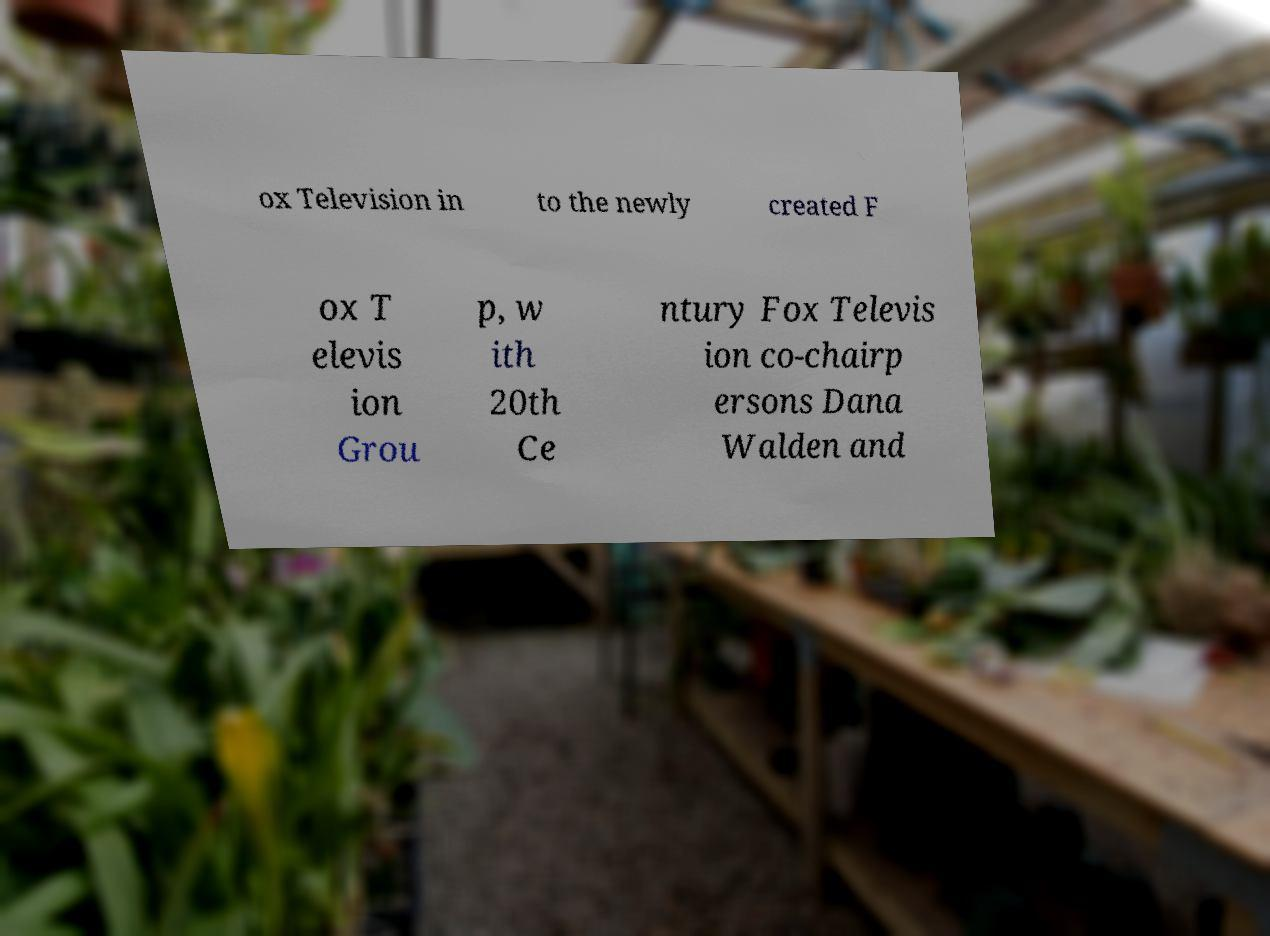What messages or text are displayed in this image? I need them in a readable, typed format. ox Television in to the newly created F ox T elevis ion Grou p, w ith 20th Ce ntury Fox Televis ion co-chairp ersons Dana Walden and 